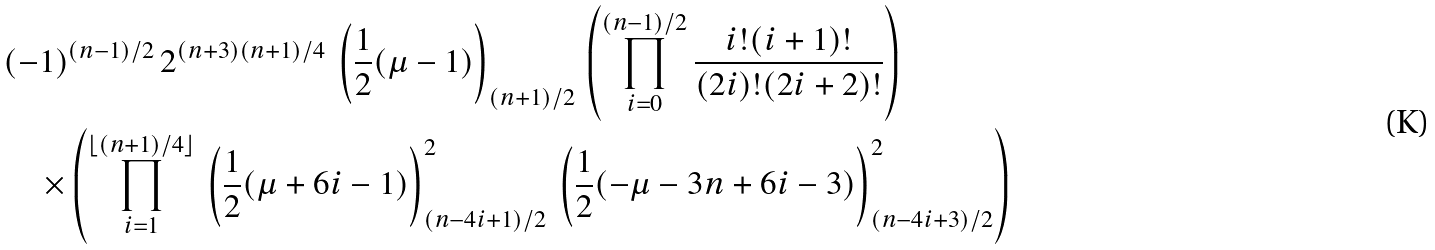<formula> <loc_0><loc_0><loc_500><loc_500>& ( - 1 ) ^ { ( n - 1 ) / 2 } \, 2 ^ { ( n + 3 ) ( n + 1 ) / 4 } \, \left ( { \frac { 1 } { 2 } ( \mu - 1 ) } \right ) _ { ( n + 1 ) / 2 } \, \left ( \prod _ { i = 0 } ^ { ( n - 1 ) / 2 } \frac { i ! ( i + 1 ) ! } { ( 2 i ) ! ( 2 i + 2 ) ! } \right ) \\ & \quad \times \left ( \prod _ { i = 1 } ^ { \lfloor ( n + 1 ) / 4 \rfloor } \, \left ( { \frac { 1 } { 2 } ( \mu + 6 i - 1 ) } \right ) _ { ( n - 4 i + 1 ) / 2 } ^ { 2 } \, \left ( { \frac { 1 } { 2 } ( - \mu - 3 n + 6 i - 3 ) } \right ) _ { ( n - 4 i + 3 ) / 2 } ^ { 2 } \right )</formula> 